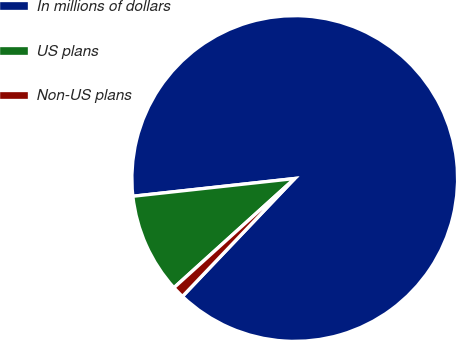<chart> <loc_0><loc_0><loc_500><loc_500><pie_chart><fcel>In millions of dollars<fcel>US plans<fcel>Non-US plans<nl><fcel>88.85%<fcel>9.96%<fcel>1.19%<nl></chart> 